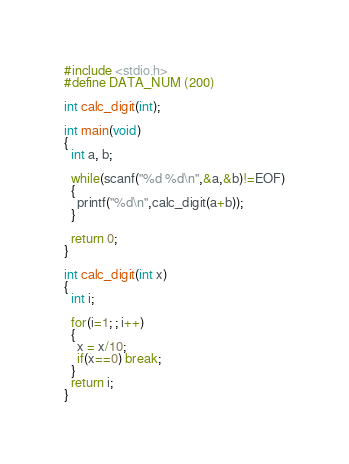Convert code to text. <code><loc_0><loc_0><loc_500><loc_500><_C_>#include <stdio.h>
#define DATA_NUM (200)

int calc_digit(int);

int main(void)
{
  int a, b;

  while(scanf("%d %d\n",&a,&b)!=EOF)
  {
    printf("%d\n",calc_digit(a+b));
  }

  return 0;		
}
	
int calc_digit(int x)
{
  int i;

  for(i=1; ; i++)
  {
    x = x/10;
	if(x==0) break;
  }  	  
  return i;
}</code> 